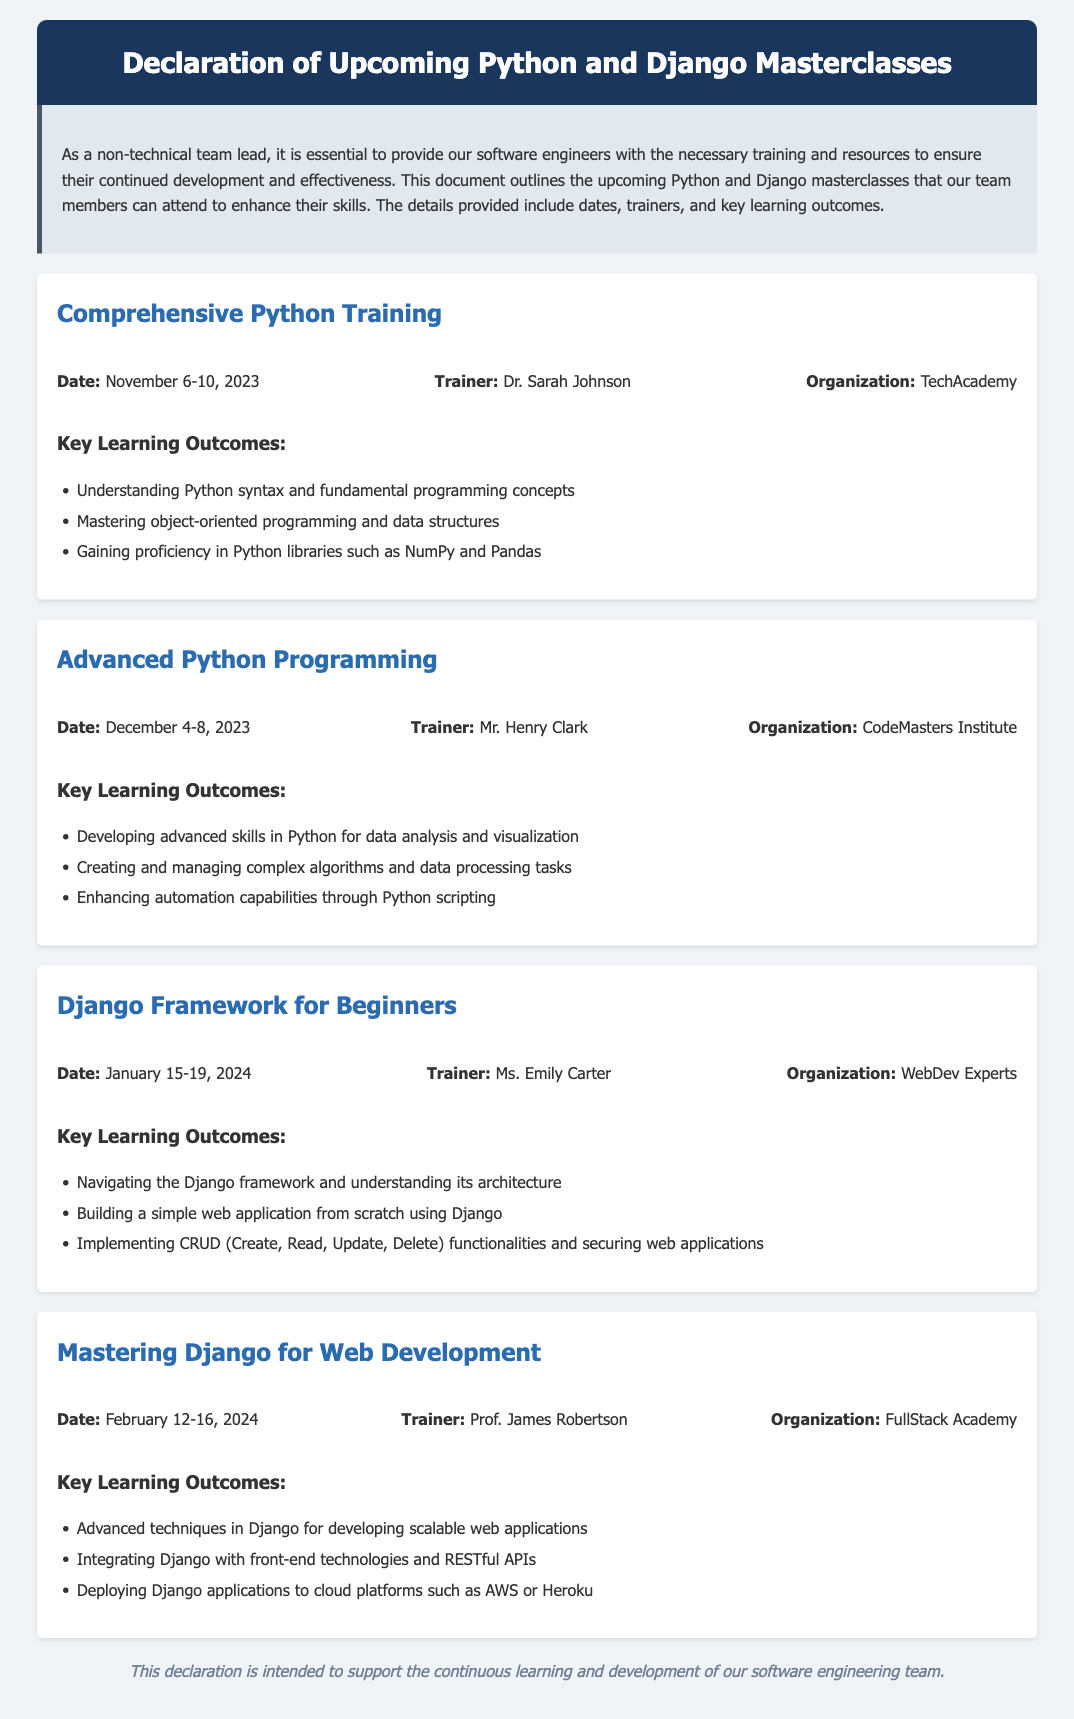What is the date of the Comprehensive Python Training? The date for the Comprehensive Python Training is mentioned in the document as November 6-10, 2023.
Answer: November 6-10, 2023 Who is the trainer for the Advanced Python Programming course? The trainer for the Advanced Python Programming course is specified as Mr. Henry Clark in the document.
Answer: Mr. Henry Clark What key learning outcome is associated with the Django Framework for Beginners? One of the key learning outcomes for the Django Framework for Beginners course is listed as building a simple web application from scratch using Django.
Answer: Building a simple web application from scratch using Django What organization is providing the Mastering Django for Web Development course? The organization providing the Mastering Django for Web Development course is noted as FullStack Academy in the document.
Answer: FullStack Academy When will the Django Framework for Beginners course take place? The timing for the Django Framework for Beginners course is indicated as January 15-19, 2024 in the document.
Answer: January 15-19, 2024 Which masterclass has the earliest start date? By comparing the dates of all courses listed in the document, the Comprehensive Python Training has the earliest start date of November 6, 2023.
Answer: Comprehensive Python Training What are the primary skills taught in Advanced Python Programming? The document details that developing advanced skills in Python for data analysis and visualization is one of the main focuses in the Advanced Python Programming course.
Answer: Developing advanced skills in Python for data analysis and visualization What is the purpose of this declaration? The purpose of the declaration is described in the introduction as intended to support the continuous learning and development of our software engineering team.
Answer: Support the continuous learning and development of our software engineering team 